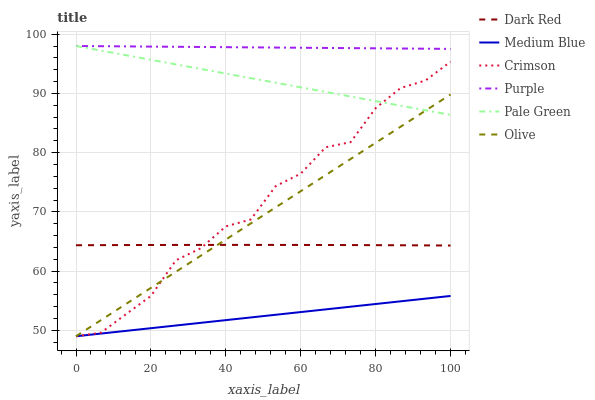Does Medium Blue have the minimum area under the curve?
Answer yes or no. Yes. Does Purple have the maximum area under the curve?
Answer yes or no. Yes. Does Dark Red have the minimum area under the curve?
Answer yes or no. No. Does Dark Red have the maximum area under the curve?
Answer yes or no. No. Is Pale Green the smoothest?
Answer yes or no. Yes. Is Crimson the roughest?
Answer yes or no. Yes. Is Dark Red the smoothest?
Answer yes or no. No. Is Dark Red the roughest?
Answer yes or no. No. Does Medium Blue have the lowest value?
Answer yes or no. Yes. Does Dark Red have the lowest value?
Answer yes or no. No. Does Pale Green have the highest value?
Answer yes or no. Yes. Does Dark Red have the highest value?
Answer yes or no. No. Is Crimson less than Purple?
Answer yes or no. Yes. Is Pale Green greater than Dark Red?
Answer yes or no. Yes. Does Olive intersect Medium Blue?
Answer yes or no. Yes. Is Olive less than Medium Blue?
Answer yes or no. No. Is Olive greater than Medium Blue?
Answer yes or no. No. Does Crimson intersect Purple?
Answer yes or no. No. 